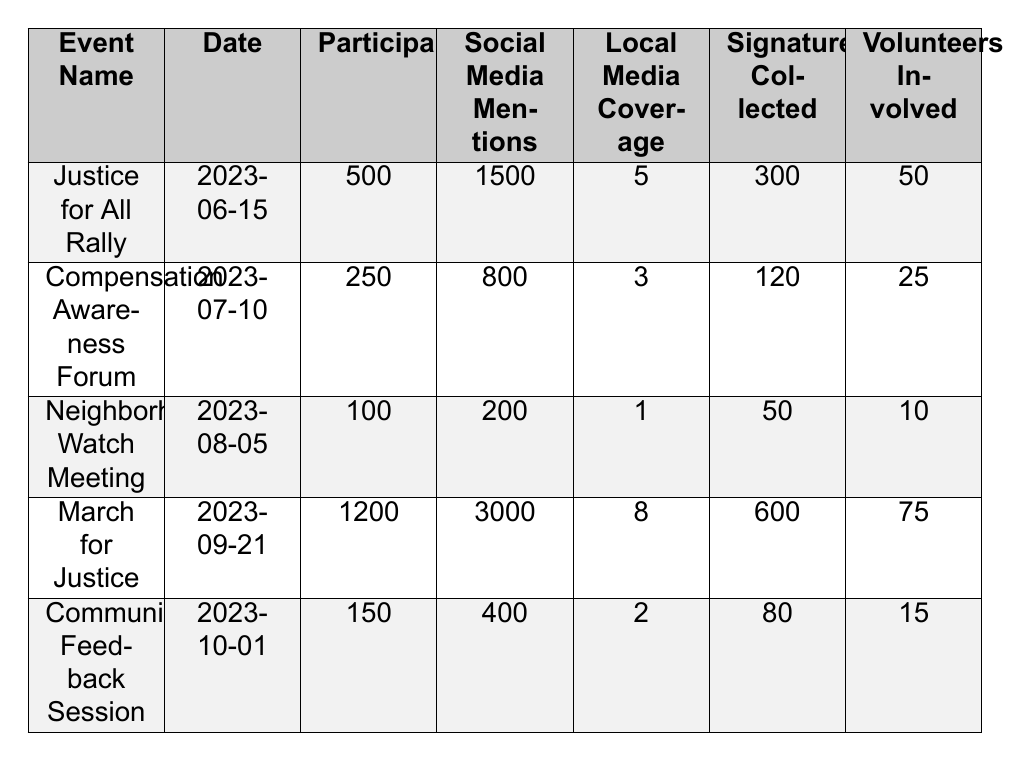What is the highest number of participants at an event? The highest number of participants is 1200 at the "March for Justice" event on 2023-09-21.
Answer: 1200 How many signatures were collected at the "Compensation Awareness Forum"? The "Compensation Awareness Forum" collected 120 signatures, as shown in the table.
Answer: 120 Which event had the most social media mentions? The "March for Justice" had the highest social media mentions with 3000 mentions.
Answer: 3000 What is the total number of volunteers involved across all events? To find the total number of volunteers, sum the volunteers from each event: 50 + 25 + 10 + 75 + 15 = 175.
Answer: 175 Did the "Neighborhood Watch Meeting" receive local media coverage? Yes, the "Neighborhood Watch Meeting" received 1 local media coverage, which indicates it was covered.
Answer: Yes What is the difference in participants between the "Justice for All Rally" and the "Compensation Awareness Forum"? The difference is calculated by subtracting participants of the forum from the rally: 500 - 250 = 250.
Answer: 250 What is the average number of social media mentions across all events? To find the average, sum the social media mentions: 1500 + 800 + 200 + 3000 + 400 = 4900; there are 5 events, so the average is 4900 / 5 = 980.
Answer: 980 Are there more signatures collected at the "March for Justice" than at the "Community Feedback Session"? Yes, the "March for Justice" collected 600 signatures, while the "Community Feedback Session" collected 80 signatures; hence, there are more signatures at the March.
Answer: Yes What was the location for the "Community Feedback Session"? The location for the "Community Feedback Session" is the "Local High School Gym," as stated in the table.
Answer: Local High School Gym If we rank events by the number of participants, what is the position of the "Compensation Awareness Forum"? The "Compensation Awareness Forum" has 250 participants; when ranked, it is the fourth event out of five, since 1200, 500, and 150 are higher.
Answer: Fourth 